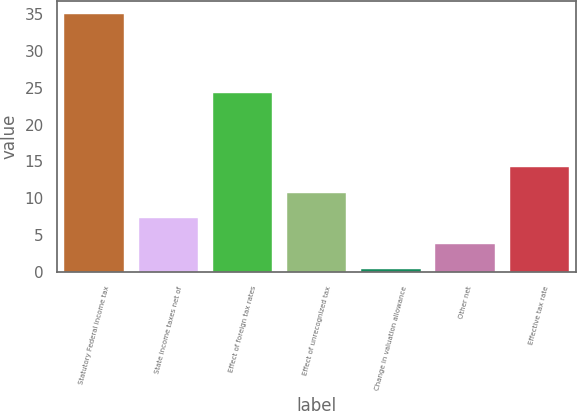Convert chart to OTSL. <chart><loc_0><loc_0><loc_500><loc_500><bar_chart><fcel>Statutory Federal income tax<fcel>State income taxes net of<fcel>Effect of foreign tax rates<fcel>Effect of unrecognized tax<fcel>Change in valuation allowance<fcel>Other net<fcel>Effective tax rate<nl><fcel>35<fcel>7.32<fcel>24.3<fcel>10.78<fcel>0.4<fcel>3.86<fcel>14.24<nl></chart> 